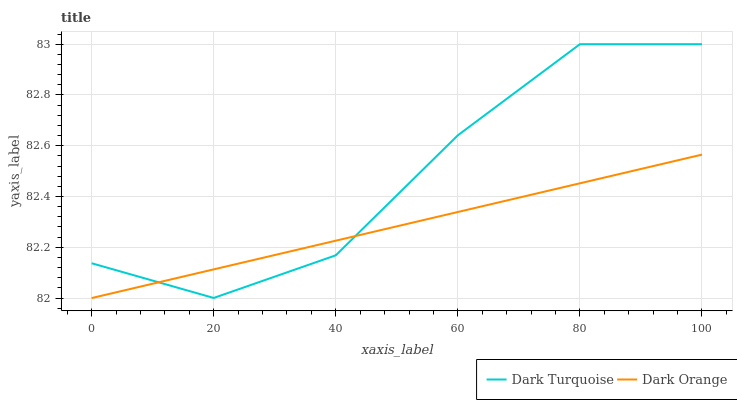Does Dark Orange have the minimum area under the curve?
Answer yes or no. Yes. Does Dark Turquoise have the maximum area under the curve?
Answer yes or no. Yes. Does Dark Orange have the maximum area under the curve?
Answer yes or no. No. Is Dark Orange the smoothest?
Answer yes or no. Yes. Is Dark Turquoise the roughest?
Answer yes or no. Yes. Is Dark Orange the roughest?
Answer yes or no. No. Does Dark Orange have the lowest value?
Answer yes or no. Yes. Does Dark Turquoise have the highest value?
Answer yes or no. Yes. Does Dark Orange have the highest value?
Answer yes or no. No. Does Dark Orange intersect Dark Turquoise?
Answer yes or no. Yes. Is Dark Orange less than Dark Turquoise?
Answer yes or no. No. Is Dark Orange greater than Dark Turquoise?
Answer yes or no. No. 